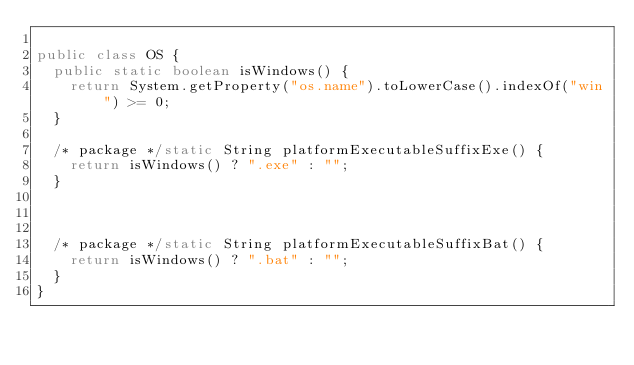Convert code to text. <code><loc_0><loc_0><loc_500><loc_500><_Java_>
public class OS {
  public static boolean isWindows() {
    return System.getProperty("os.name").toLowerCase().indexOf("win") >= 0;
  }

  /* package */static String platformExecutableSuffixExe() {
    return isWindows() ? ".exe" : "";
  }



  /* package */static String platformExecutableSuffixBat() {
    return isWindows() ? ".bat" : "";
  }
}
</code> 